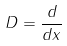<formula> <loc_0><loc_0><loc_500><loc_500>D = \frac { d } { d x }</formula> 